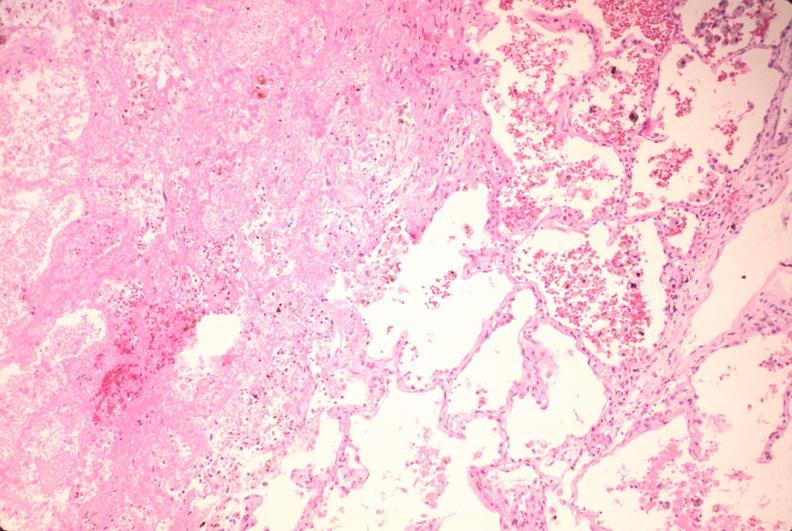where is this?
Answer the question using a single word or phrase. Lung 